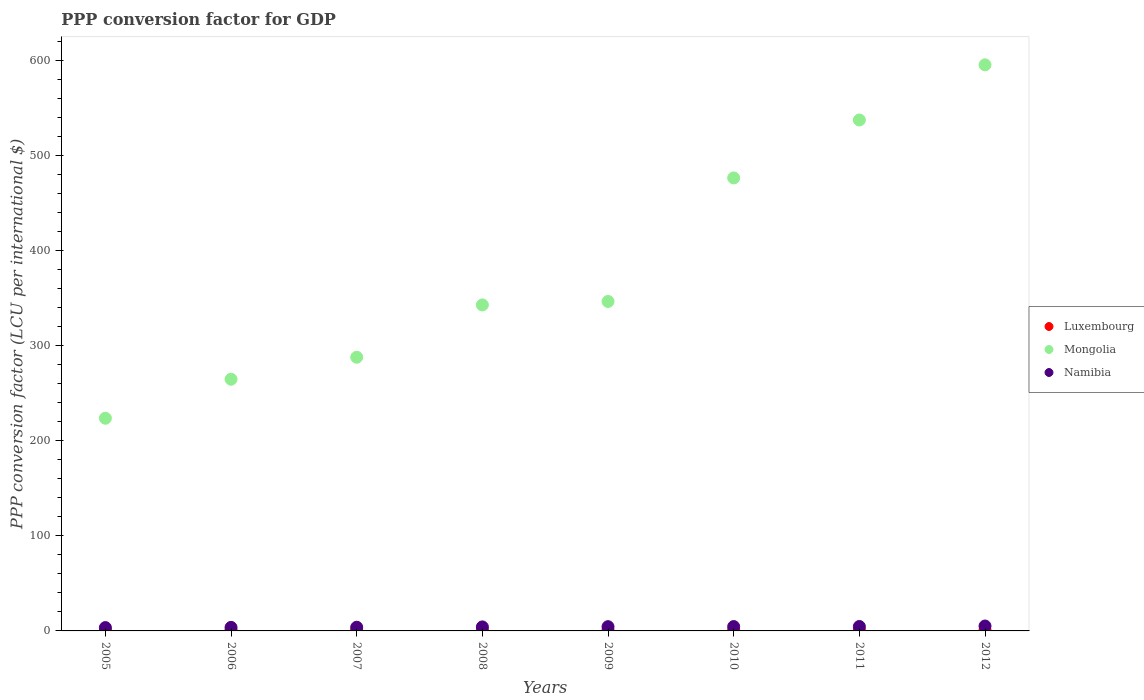What is the PPP conversion factor for GDP in Mongolia in 2012?
Provide a succinct answer. 595.11. Across all years, what is the maximum PPP conversion factor for GDP in Namibia?
Keep it short and to the point. 5.17. Across all years, what is the minimum PPP conversion factor for GDP in Mongolia?
Keep it short and to the point. 223.58. In which year was the PPP conversion factor for GDP in Mongolia maximum?
Provide a succinct answer. 2012. In which year was the PPP conversion factor for GDP in Luxembourg minimum?
Give a very brief answer. 2011. What is the total PPP conversion factor for GDP in Luxembourg in the graph?
Make the answer very short. 7.32. What is the difference between the PPP conversion factor for GDP in Mongolia in 2008 and that in 2011?
Provide a succinct answer. -194.41. What is the difference between the PPP conversion factor for GDP in Luxembourg in 2005 and the PPP conversion factor for GDP in Namibia in 2008?
Give a very brief answer. -3.27. What is the average PPP conversion factor for GDP in Namibia per year?
Your answer should be compact. 4.28. In the year 2007, what is the difference between the PPP conversion factor for GDP in Luxembourg and PPP conversion factor for GDP in Namibia?
Keep it short and to the point. -2.96. What is the ratio of the PPP conversion factor for GDP in Luxembourg in 2009 to that in 2011?
Offer a terse response. 1.01. Is the PPP conversion factor for GDP in Namibia in 2005 less than that in 2009?
Offer a terse response. Yes. What is the difference between the highest and the second highest PPP conversion factor for GDP in Luxembourg?
Offer a terse response. 0.03. What is the difference between the highest and the lowest PPP conversion factor for GDP in Mongolia?
Keep it short and to the point. 371.53. Does the PPP conversion factor for GDP in Mongolia monotonically increase over the years?
Offer a terse response. Yes. Is the PPP conversion factor for GDP in Luxembourg strictly less than the PPP conversion factor for GDP in Namibia over the years?
Offer a terse response. Yes. How many years are there in the graph?
Give a very brief answer. 8. What is the difference between two consecutive major ticks on the Y-axis?
Your response must be concise. 100. Are the values on the major ticks of Y-axis written in scientific E-notation?
Your response must be concise. No. Where does the legend appear in the graph?
Make the answer very short. Center right. What is the title of the graph?
Keep it short and to the point. PPP conversion factor for GDP. What is the label or title of the Y-axis?
Offer a terse response. PPP conversion factor (LCU per international $). What is the PPP conversion factor (LCU per international $) in Luxembourg in 2005?
Provide a succinct answer. 0.95. What is the PPP conversion factor (LCU per international $) of Mongolia in 2005?
Offer a very short reply. 223.58. What is the PPP conversion factor (LCU per international $) in Namibia in 2005?
Your answer should be compact. 3.52. What is the PPP conversion factor (LCU per international $) of Luxembourg in 2006?
Offer a terse response. 0.91. What is the PPP conversion factor (LCU per international $) in Mongolia in 2006?
Ensure brevity in your answer.  264.61. What is the PPP conversion factor (LCU per international $) of Namibia in 2006?
Provide a succinct answer. 3.73. What is the PPP conversion factor (LCU per international $) of Luxembourg in 2007?
Offer a very short reply. 0.92. What is the PPP conversion factor (LCU per international $) in Mongolia in 2007?
Your answer should be compact. 287.72. What is the PPP conversion factor (LCU per international $) in Namibia in 2007?
Make the answer very short. 3.88. What is the PPP conversion factor (LCU per international $) of Luxembourg in 2008?
Make the answer very short. 0.91. What is the PPP conversion factor (LCU per international $) in Mongolia in 2008?
Give a very brief answer. 342.71. What is the PPP conversion factor (LCU per international $) of Namibia in 2008?
Offer a very short reply. 4.22. What is the PPP conversion factor (LCU per international $) in Luxembourg in 2009?
Make the answer very short. 0.91. What is the PPP conversion factor (LCU per international $) of Mongolia in 2009?
Offer a terse response. 346.34. What is the PPP conversion factor (LCU per international $) of Namibia in 2009?
Offer a very short reply. 4.48. What is the PPP conversion factor (LCU per international $) of Luxembourg in 2010?
Offer a terse response. 0.92. What is the PPP conversion factor (LCU per international $) in Mongolia in 2010?
Provide a succinct answer. 476.22. What is the PPP conversion factor (LCU per international $) of Namibia in 2010?
Ensure brevity in your answer.  4.59. What is the PPP conversion factor (LCU per international $) of Luxembourg in 2011?
Your response must be concise. 0.89. What is the PPP conversion factor (LCU per international $) in Mongolia in 2011?
Your response must be concise. 537.13. What is the PPP conversion factor (LCU per international $) of Namibia in 2011?
Keep it short and to the point. 4.66. What is the PPP conversion factor (LCU per international $) of Luxembourg in 2012?
Your answer should be compact. 0.9. What is the PPP conversion factor (LCU per international $) of Mongolia in 2012?
Your response must be concise. 595.11. What is the PPP conversion factor (LCU per international $) in Namibia in 2012?
Make the answer very short. 5.17. Across all years, what is the maximum PPP conversion factor (LCU per international $) of Luxembourg?
Keep it short and to the point. 0.95. Across all years, what is the maximum PPP conversion factor (LCU per international $) of Mongolia?
Your answer should be compact. 595.11. Across all years, what is the maximum PPP conversion factor (LCU per international $) in Namibia?
Give a very brief answer. 5.17. Across all years, what is the minimum PPP conversion factor (LCU per international $) of Luxembourg?
Your answer should be compact. 0.89. Across all years, what is the minimum PPP conversion factor (LCU per international $) in Mongolia?
Ensure brevity in your answer.  223.58. Across all years, what is the minimum PPP conversion factor (LCU per international $) of Namibia?
Provide a short and direct response. 3.52. What is the total PPP conversion factor (LCU per international $) of Luxembourg in the graph?
Make the answer very short. 7.32. What is the total PPP conversion factor (LCU per international $) of Mongolia in the graph?
Offer a terse response. 3073.42. What is the total PPP conversion factor (LCU per international $) of Namibia in the graph?
Provide a succinct answer. 34.24. What is the difference between the PPP conversion factor (LCU per international $) of Luxembourg in 2005 and that in 2006?
Provide a short and direct response. 0.04. What is the difference between the PPP conversion factor (LCU per international $) in Mongolia in 2005 and that in 2006?
Give a very brief answer. -41.03. What is the difference between the PPP conversion factor (LCU per international $) in Namibia in 2005 and that in 2006?
Give a very brief answer. -0.21. What is the difference between the PPP conversion factor (LCU per international $) in Luxembourg in 2005 and that in 2007?
Keep it short and to the point. 0.03. What is the difference between the PPP conversion factor (LCU per international $) of Mongolia in 2005 and that in 2007?
Your answer should be compact. -64.14. What is the difference between the PPP conversion factor (LCU per international $) in Namibia in 2005 and that in 2007?
Ensure brevity in your answer.  -0.37. What is the difference between the PPP conversion factor (LCU per international $) of Luxembourg in 2005 and that in 2008?
Your response must be concise. 0.05. What is the difference between the PPP conversion factor (LCU per international $) of Mongolia in 2005 and that in 2008?
Make the answer very short. -119.13. What is the difference between the PPP conversion factor (LCU per international $) in Namibia in 2005 and that in 2008?
Your answer should be compact. -0.71. What is the difference between the PPP conversion factor (LCU per international $) of Luxembourg in 2005 and that in 2009?
Provide a succinct answer. 0.05. What is the difference between the PPP conversion factor (LCU per international $) in Mongolia in 2005 and that in 2009?
Your answer should be compact. -122.76. What is the difference between the PPP conversion factor (LCU per international $) of Namibia in 2005 and that in 2009?
Offer a terse response. -0.97. What is the difference between the PPP conversion factor (LCU per international $) of Luxembourg in 2005 and that in 2010?
Your answer should be compact. 0.03. What is the difference between the PPP conversion factor (LCU per international $) in Mongolia in 2005 and that in 2010?
Keep it short and to the point. -252.64. What is the difference between the PPP conversion factor (LCU per international $) in Namibia in 2005 and that in 2010?
Your answer should be compact. -1.07. What is the difference between the PPP conversion factor (LCU per international $) of Luxembourg in 2005 and that in 2011?
Your answer should be very brief. 0.06. What is the difference between the PPP conversion factor (LCU per international $) of Mongolia in 2005 and that in 2011?
Offer a very short reply. -313.55. What is the difference between the PPP conversion factor (LCU per international $) of Namibia in 2005 and that in 2011?
Your response must be concise. -1.15. What is the difference between the PPP conversion factor (LCU per international $) of Luxembourg in 2005 and that in 2012?
Offer a very short reply. 0.05. What is the difference between the PPP conversion factor (LCU per international $) in Mongolia in 2005 and that in 2012?
Your answer should be compact. -371.53. What is the difference between the PPP conversion factor (LCU per international $) in Namibia in 2005 and that in 2012?
Make the answer very short. -1.66. What is the difference between the PPP conversion factor (LCU per international $) in Luxembourg in 2006 and that in 2007?
Offer a terse response. -0.01. What is the difference between the PPP conversion factor (LCU per international $) in Mongolia in 2006 and that in 2007?
Provide a succinct answer. -23.11. What is the difference between the PPP conversion factor (LCU per international $) of Namibia in 2006 and that in 2007?
Make the answer very short. -0.15. What is the difference between the PPP conversion factor (LCU per international $) in Luxembourg in 2006 and that in 2008?
Your response must be concise. 0.01. What is the difference between the PPP conversion factor (LCU per international $) in Mongolia in 2006 and that in 2008?
Your answer should be compact. -78.1. What is the difference between the PPP conversion factor (LCU per international $) in Namibia in 2006 and that in 2008?
Offer a very short reply. -0.49. What is the difference between the PPP conversion factor (LCU per international $) in Luxembourg in 2006 and that in 2009?
Your answer should be compact. 0.01. What is the difference between the PPP conversion factor (LCU per international $) of Mongolia in 2006 and that in 2009?
Your answer should be very brief. -81.73. What is the difference between the PPP conversion factor (LCU per international $) in Namibia in 2006 and that in 2009?
Provide a short and direct response. -0.75. What is the difference between the PPP conversion factor (LCU per international $) of Luxembourg in 2006 and that in 2010?
Your answer should be very brief. -0.01. What is the difference between the PPP conversion factor (LCU per international $) in Mongolia in 2006 and that in 2010?
Ensure brevity in your answer.  -211.61. What is the difference between the PPP conversion factor (LCU per international $) in Namibia in 2006 and that in 2010?
Ensure brevity in your answer.  -0.86. What is the difference between the PPP conversion factor (LCU per international $) of Luxembourg in 2006 and that in 2011?
Provide a short and direct response. 0.02. What is the difference between the PPP conversion factor (LCU per international $) of Mongolia in 2006 and that in 2011?
Offer a very short reply. -272.52. What is the difference between the PPP conversion factor (LCU per international $) in Namibia in 2006 and that in 2011?
Make the answer very short. -0.94. What is the difference between the PPP conversion factor (LCU per international $) in Luxembourg in 2006 and that in 2012?
Make the answer very short. 0.02. What is the difference between the PPP conversion factor (LCU per international $) of Mongolia in 2006 and that in 2012?
Provide a succinct answer. -330.5. What is the difference between the PPP conversion factor (LCU per international $) of Namibia in 2006 and that in 2012?
Provide a succinct answer. -1.44. What is the difference between the PPP conversion factor (LCU per international $) in Luxembourg in 2007 and that in 2008?
Provide a short and direct response. 0.02. What is the difference between the PPP conversion factor (LCU per international $) in Mongolia in 2007 and that in 2008?
Give a very brief answer. -54.99. What is the difference between the PPP conversion factor (LCU per international $) of Namibia in 2007 and that in 2008?
Your answer should be compact. -0.34. What is the difference between the PPP conversion factor (LCU per international $) of Luxembourg in 2007 and that in 2009?
Offer a very short reply. 0.02. What is the difference between the PPP conversion factor (LCU per international $) in Mongolia in 2007 and that in 2009?
Provide a succinct answer. -58.62. What is the difference between the PPP conversion factor (LCU per international $) in Namibia in 2007 and that in 2009?
Your answer should be very brief. -0.6. What is the difference between the PPP conversion factor (LCU per international $) of Luxembourg in 2007 and that in 2010?
Ensure brevity in your answer.  0. What is the difference between the PPP conversion factor (LCU per international $) in Mongolia in 2007 and that in 2010?
Offer a terse response. -188.49. What is the difference between the PPP conversion factor (LCU per international $) in Namibia in 2007 and that in 2010?
Give a very brief answer. -0.7. What is the difference between the PPP conversion factor (LCU per international $) in Mongolia in 2007 and that in 2011?
Offer a terse response. -249.41. What is the difference between the PPP conversion factor (LCU per international $) in Namibia in 2007 and that in 2011?
Offer a very short reply. -0.78. What is the difference between the PPP conversion factor (LCU per international $) of Luxembourg in 2007 and that in 2012?
Provide a short and direct response. 0.03. What is the difference between the PPP conversion factor (LCU per international $) in Mongolia in 2007 and that in 2012?
Your answer should be compact. -307.39. What is the difference between the PPP conversion factor (LCU per international $) of Namibia in 2007 and that in 2012?
Ensure brevity in your answer.  -1.29. What is the difference between the PPP conversion factor (LCU per international $) in Luxembourg in 2008 and that in 2009?
Your answer should be compact. -0. What is the difference between the PPP conversion factor (LCU per international $) of Mongolia in 2008 and that in 2009?
Ensure brevity in your answer.  -3.63. What is the difference between the PPP conversion factor (LCU per international $) of Namibia in 2008 and that in 2009?
Offer a terse response. -0.26. What is the difference between the PPP conversion factor (LCU per international $) in Luxembourg in 2008 and that in 2010?
Provide a short and direct response. -0.02. What is the difference between the PPP conversion factor (LCU per international $) in Mongolia in 2008 and that in 2010?
Your answer should be very brief. -133.5. What is the difference between the PPP conversion factor (LCU per international $) in Namibia in 2008 and that in 2010?
Provide a short and direct response. -0.36. What is the difference between the PPP conversion factor (LCU per international $) in Luxembourg in 2008 and that in 2011?
Your response must be concise. 0.01. What is the difference between the PPP conversion factor (LCU per international $) in Mongolia in 2008 and that in 2011?
Provide a short and direct response. -194.41. What is the difference between the PPP conversion factor (LCU per international $) of Namibia in 2008 and that in 2011?
Your response must be concise. -0.44. What is the difference between the PPP conversion factor (LCU per international $) of Luxembourg in 2008 and that in 2012?
Make the answer very short. 0.01. What is the difference between the PPP conversion factor (LCU per international $) of Mongolia in 2008 and that in 2012?
Your answer should be compact. -252.4. What is the difference between the PPP conversion factor (LCU per international $) in Namibia in 2008 and that in 2012?
Your response must be concise. -0.95. What is the difference between the PPP conversion factor (LCU per international $) of Luxembourg in 2009 and that in 2010?
Offer a very short reply. -0.02. What is the difference between the PPP conversion factor (LCU per international $) of Mongolia in 2009 and that in 2010?
Provide a short and direct response. -129.87. What is the difference between the PPP conversion factor (LCU per international $) in Namibia in 2009 and that in 2010?
Offer a very short reply. -0.1. What is the difference between the PPP conversion factor (LCU per international $) of Luxembourg in 2009 and that in 2011?
Offer a terse response. 0.01. What is the difference between the PPP conversion factor (LCU per international $) in Mongolia in 2009 and that in 2011?
Keep it short and to the point. -190.78. What is the difference between the PPP conversion factor (LCU per international $) of Namibia in 2009 and that in 2011?
Make the answer very short. -0.18. What is the difference between the PPP conversion factor (LCU per international $) of Luxembourg in 2009 and that in 2012?
Offer a very short reply. 0.01. What is the difference between the PPP conversion factor (LCU per international $) in Mongolia in 2009 and that in 2012?
Make the answer very short. -248.77. What is the difference between the PPP conversion factor (LCU per international $) in Namibia in 2009 and that in 2012?
Make the answer very short. -0.69. What is the difference between the PPP conversion factor (LCU per international $) of Luxembourg in 2010 and that in 2011?
Offer a terse response. 0.03. What is the difference between the PPP conversion factor (LCU per international $) of Mongolia in 2010 and that in 2011?
Keep it short and to the point. -60.91. What is the difference between the PPP conversion factor (LCU per international $) of Namibia in 2010 and that in 2011?
Provide a succinct answer. -0.08. What is the difference between the PPP conversion factor (LCU per international $) in Luxembourg in 2010 and that in 2012?
Give a very brief answer. 0.02. What is the difference between the PPP conversion factor (LCU per international $) in Mongolia in 2010 and that in 2012?
Offer a very short reply. -118.9. What is the difference between the PPP conversion factor (LCU per international $) in Namibia in 2010 and that in 2012?
Make the answer very short. -0.59. What is the difference between the PPP conversion factor (LCU per international $) of Luxembourg in 2011 and that in 2012?
Give a very brief answer. -0. What is the difference between the PPP conversion factor (LCU per international $) in Mongolia in 2011 and that in 2012?
Your answer should be compact. -57.98. What is the difference between the PPP conversion factor (LCU per international $) of Namibia in 2011 and that in 2012?
Your answer should be very brief. -0.51. What is the difference between the PPP conversion factor (LCU per international $) of Luxembourg in 2005 and the PPP conversion factor (LCU per international $) of Mongolia in 2006?
Your answer should be very brief. -263.66. What is the difference between the PPP conversion factor (LCU per international $) in Luxembourg in 2005 and the PPP conversion factor (LCU per international $) in Namibia in 2006?
Provide a succinct answer. -2.77. What is the difference between the PPP conversion factor (LCU per international $) in Mongolia in 2005 and the PPP conversion factor (LCU per international $) in Namibia in 2006?
Your response must be concise. 219.85. What is the difference between the PPP conversion factor (LCU per international $) in Luxembourg in 2005 and the PPP conversion factor (LCU per international $) in Mongolia in 2007?
Offer a terse response. -286.77. What is the difference between the PPP conversion factor (LCU per international $) in Luxembourg in 2005 and the PPP conversion factor (LCU per international $) in Namibia in 2007?
Your answer should be very brief. -2.93. What is the difference between the PPP conversion factor (LCU per international $) of Mongolia in 2005 and the PPP conversion factor (LCU per international $) of Namibia in 2007?
Offer a terse response. 219.7. What is the difference between the PPP conversion factor (LCU per international $) of Luxembourg in 2005 and the PPP conversion factor (LCU per international $) of Mongolia in 2008?
Provide a succinct answer. -341.76. What is the difference between the PPP conversion factor (LCU per international $) in Luxembourg in 2005 and the PPP conversion factor (LCU per international $) in Namibia in 2008?
Make the answer very short. -3.27. What is the difference between the PPP conversion factor (LCU per international $) of Mongolia in 2005 and the PPP conversion factor (LCU per international $) of Namibia in 2008?
Your answer should be very brief. 219.36. What is the difference between the PPP conversion factor (LCU per international $) of Luxembourg in 2005 and the PPP conversion factor (LCU per international $) of Mongolia in 2009?
Make the answer very short. -345.39. What is the difference between the PPP conversion factor (LCU per international $) of Luxembourg in 2005 and the PPP conversion factor (LCU per international $) of Namibia in 2009?
Ensure brevity in your answer.  -3.53. What is the difference between the PPP conversion factor (LCU per international $) in Mongolia in 2005 and the PPP conversion factor (LCU per international $) in Namibia in 2009?
Give a very brief answer. 219.1. What is the difference between the PPP conversion factor (LCU per international $) in Luxembourg in 2005 and the PPP conversion factor (LCU per international $) in Mongolia in 2010?
Your response must be concise. -475.26. What is the difference between the PPP conversion factor (LCU per international $) of Luxembourg in 2005 and the PPP conversion factor (LCU per international $) of Namibia in 2010?
Give a very brief answer. -3.63. What is the difference between the PPP conversion factor (LCU per international $) in Mongolia in 2005 and the PPP conversion factor (LCU per international $) in Namibia in 2010?
Your answer should be very brief. 219. What is the difference between the PPP conversion factor (LCU per international $) in Luxembourg in 2005 and the PPP conversion factor (LCU per international $) in Mongolia in 2011?
Your response must be concise. -536.17. What is the difference between the PPP conversion factor (LCU per international $) of Luxembourg in 2005 and the PPP conversion factor (LCU per international $) of Namibia in 2011?
Keep it short and to the point. -3.71. What is the difference between the PPP conversion factor (LCU per international $) of Mongolia in 2005 and the PPP conversion factor (LCU per international $) of Namibia in 2011?
Keep it short and to the point. 218.92. What is the difference between the PPP conversion factor (LCU per international $) of Luxembourg in 2005 and the PPP conversion factor (LCU per international $) of Mongolia in 2012?
Your answer should be very brief. -594.16. What is the difference between the PPP conversion factor (LCU per international $) in Luxembourg in 2005 and the PPP conversion factor (LCU per international $) in Namibia in 2012?
Give a very brief answer. -4.22. What is the difference between the PPP conversion factor (LCU per international $) in Mongolia in 2005 and the PPP conversion factor (LCU per international $) in Namibia in 2012?
Give a very brief answer. 218.41. What is the difference between the PPP conversion factor (LCU per international $) in Luxembourg in 2006 and the PPP conversion factor (LCU per international $) in Mongolia in 2007?
Your answer should be compact. -286.81. What is the difference between the PPP conversion factor (LCU per international $) in Luxembourg in 2006 and the PPP conversion factor (LCU per international $) in Namibia in 2007?
Your answer should be compact. -2.97. What is the difference between the PPP conversion factor (LCU per international $) of Mongolia in 2006 and the PPP conversion factor (LCU per international $) of Namibia in 2007?
Make the answer very short. 260.73. What is the difference between the PPP conversion factor (LCU per international $) of Luxembourg in 2006 and the PPP conversion factor (LCU per international $) of Mongolia in 2008?
Make the answer very short. -341.8. What is the difference between the PPP conversion factor (LCU per international $) of Luxembourg in 2006 and the PPP conversion factor (LCU per international $) of Namibia in 2008?
Your answer should be very brief. -3.31. What is the difference between the PPP conversion factor (LCU per international $) in Mongolia in 2006 and the PPP conversion factor (LCU per international $) in Namibia in 2008?
Give a very brief answer. 260.39. What is the difference between the PPP conversion factor (LCU per international $) of Luxembourg in 2006 and the PPP conversion factor (LCU per international $) of Mongolia in 2009?
Keep it short and to the point. -345.43. What is the difference between the PPP conversion factor (LCU per international $) of Luxembourg in 2006 and the PPP conversion factor (LCU per international $) of Namibia in 2009?
Ensure brevity in your answer.  -3.57. What is the difference between the PPP conversion factor (LCU per international $) in Mongolia in 2006 and the PPP conversion factor (LCU per international $) in Namibia in 2009?
Provide a short and direct response. 260.13. What is the difference between the PPP conversion factor (LCU per international $) in Luxembourg in 2006 and the PPP conversion factor (LCU per international $) in Mongolia in 2010?
Your answer should be very brief. -475.3. What is the difference between the PPP conversion factor (LCU per international $) of Luxembourg in 2006 and the PPP conversion factor (LCU per international $) of Namibia in 2010?
Give a very brief answer. -3.67. What is the difference between the PPP conversion factor (LCU per international $) of Mongolia in 2006 and the PPP conversion factor (LCU per international $) of Namibia in 2010?
Provide a short and direct response. 260.02. What is the difference between the PPP conversion factor (LCU per international $) in Luxembourg in 2006 and the PPP conversion factor (LCU per international $) in Mongolia in 2011?
Keep it short and to the point. -536.21. What is the difference between the PPP conversion factor (LCU per international $) of Luxembourg in 2006 and the PPP conversion factor (LCU per international $) of Namibia in 2011?
Ensure brevity in your answer.  -3.75. What is the difference between the PPP conversion factor (LCU per international $) in Mongolia in 2006 and the PPP conversion factor (LCU per international $) in Namibia in 2011?
Your answer should be very brief. 259.95. What is the difference between the PPP conversion factor (LCU per international $) of Luxembourg in 2006 and the PPP conversion factor (LCU per international $) of Mongolia in 2012?
Give a very brief answer. -594.2. What is the difference between the PPP conversion factor (LCU per international $) of Luxembourg in 2006 and the PPP conversion factor (LCU per international $) of Namibia in 2012?
Your answer should be compact. -4.26. What is the difference between the PPP conversion factor (LCU per international $) in Mongolia in 2006 and the PPP conversion factor (LCU per international $) in Namibia in 2012?
Your answer should be very brief. 259.44. What is the difference between the PPP conversion factor (LCU per international $) in Luxembourg in 2007 and the PPP conversion factor (LCU per international $) in Mongolia in 2008?
Provide a short and direct response. -341.79. What is the difference between the PPP conversion factor (LCU per international $) of Luxembourg in 2007 and the PPP conversion factor (LCU per international $) of Namibia in 2008?
Keep it short and to the point. -3.3. What is the difference between the PPP conversion factor (LCU per international $) in Mongolia in 2007 and the PPP conversion factor (LCU per international $) in Namibia in 2008?
Make the answer very short. 283.5. What is the difference between the PPP conversion factor (LCU per international $) of Luxembourg in 2007 and the PPP conversion factor (LCU per international $) of Mongolia in 2009?
Provide a short and direct response. -345.42. What is the difference between the PPP conversion factor (LCU per international $) of Luxembourg in 2007 and the PPP conversion factor (LCU per international $) of Namibia in 2009?
Keep it short and to the point. -3.56. What is the difference between the PPP conversion factor (LCU per international $) of Mongolia in 2007 and the PPP conversion factor (LCU per international $) of Namibia in 2009?
Your response must be concise. 283.24. What is the difference between the PPP conversion factor (LCU per international $) in Luxembourg in 2007 and the PPP conversion factor (LCU per international $) in Mongolia in 2010?
Your answer should be very brief. -475.29. What is the difference between the PPP conversion factor (LCU per international $) in Luxembourg in 2007 and the PPP conversion factor (LCU per international $) in Namibia in 2010?
Keep it short and to the point. -3.66. What is the difference between the PPP conversion factor (LCU per international $) of Mongolia in 2007 and the PPP conversion factor (LCU per international $) of Namibia in 2010?
Offer a very short reply. 283.14. What is the difference between the PPP conversion factor (LCU per international $) in Luxembourg in 2007 and the PPP conversion factor (LCU per international $) in Mongolia in 2011?
Offer a very short reply. -536.2. What is the difference between the PPP conversion factor (LCU per international $) of Luxembourg in 2007 and the PPP conversion factor (LCU per international $) of Namibia in 2011?
Offer a very short reply. -3.74. What is the difference between the PPP conversion factor (LCU per international $) of Mongolia in 2007 and the PPP conversion factor (LCU per international $) of Namibia in 2011?
Your response must be concise. 283.06. What is the difference between the PPP conversion factor (LCU per international $) in Luxembourg in 2007 and the PPP conversion factor (LCU per international $) in Mongolia in 2012?
Provide a succinct answer. -594.19. What is the difference between the PPP conversion factor (LCU per international $) in Luxembourg in 2007 and the PPP conversion factor (LCU per international $) in Namibia in 2012?
Your answer should be very brief. -4.25. What is the difference between the PPP conversion factor (LCU per international $) in Mongolia in 2007 and the PPP conversion factor (LCU per international $) in Namibia in 2012?
Offer a terse response. 282.55. What is the difference between the PPP conversion factor (LCU per international $) of Luxembourg in 2008 and the PPP conversion factor (LCU per international $) of Mongolia in 2009?
Ensure brevity in your answer.  -345.44. What is the difference between the PPP conversion factor (LCU per international $) of Luxembourg in 2008 and the PPP conversion factor (LCU per international $) of Namibia in 2009?
Your answer should be very brief. -3.58. What is the difference between the PPP conversion factor (LCU per international $) in Mongolia in 2008 and the PPP conversion factor (LCU per international $) in Namibia in 2009?
Keep it short and to the point. 338.23. What is the difference between the PPP conversion factor (LCU per international $) of Luxembourg in 2008 and the PPP conversion factor (LCU per international $) of Mongolia in 2010?
Make the answer very short. -475.31. What is the difference between the PPP conversion factor (LCU per international $) in Luxembourg in 2008 and the PPP conversion factor (LCU per international $) in Namibia in 2010?
Keep it short and to the point. -3.68. What is the difference between the PPP conversion factor (LCU per international $) of Mongolia in 2008 and the PPP conversion factor (LCU per international $) of Namibia in 2010?
Your answer should be very brief. 338.13. What is the difference between the PPP conversion factor (LCU per international $) in Luxembourg in 2008 and the PPP conversion factor (LCU per international $) in Mongolia in 2011?
Provide a succinct answer. -536.22. What is the difference between the PPP conversion factor (LCU per international $) in Luxembourg in 2008 and the PPP conversion factor (LCU per international $) in Namibia in 2011?
Offer a terse response. -3.76. What is the difference between the PPP conversion factor (LCU per international $) in Mongolia in 2008 and the PPP conversion factor (LCU per international $) in Namibia in 2011?
Your answer should be compact. 338.05. What is the difference between the PPP conversion factor (LCU per international $) of Luxembourg in 2008 and the PPP conversion factor (LCU per international $) of Mongolia in 2012?
Provide a succinct answer. -594.21. What is the difference between the PPP conversion factor (LCU per international $) of Luxembourg in 2008 and the PPP conversion factor (LCU per international $) of Namibia in 2012?
Offer a very short reply. -4.26. What is the difference between the PPP conversion factor (LCU per international $) in Mongolia in 2008 and the PPP conversion factor (LCU per international $) in Namibia in 2012?
Keep it short and to the point. 337.54. What is the difference between the PPP conversion factor (LCU per international $) of Luxembourg in 2009 and the PPP conversion factor (LCU per international $) of Mongolia in 2010?
Ensure brevity in your answer.  -475.31. What is the difference between the PPP conversion factor (LCU per international $) in Luxembourg in 2009 and the PPP conversion factor (LCU per international $) in Namibia in 2010?
Keep it short and to the point. -3.68. What is the difference between the PPP conversion factor (LCU per international $) in Mongolia in 2009 and the PPP conversion factor (LCU per international $) in Namibia in 2010?
Provide a short and direct response. 341.76. What is the difference between the PPP conversion factor (LCU per international $) in Luxembourg in 2009 and the PPP conversion factor (LCU per international $) in Mongolia in 2011?
Your answer should be compact. -536.22. What is the difference between the PPP conversion factor (LCU per international $) in Luxembourg in 2009 and the PPP conversion factor (LCU per international $) in Namibia in 2011?
Ensure brevity in your answer.  -3.76. What is the difference between the PPP conversion factor (LCU per international $) in Mongolia in 2009 and the PPP conversion factor (LCU per international $) in Namibia in 2011?
Your answer should be very brief. 341.68. What is the difference between the PPP conversion factor (LCU per international $) of Luxembourg in 2009 and the PPP conversion factor (LCU per international $) of Mongolia in 2012?
Keep it short and to the point. -594.2. What is the difference between the PPP conversion factor (LCU per international $) of Luxembourg in 2009 and the PPP conversion factor (LCU per international $) of Namibia in 2012?
Keep it short and to the point. -4.26. What is the difference between the PPP conversion factor (LCU per international $) in Mongolia in 2009 and the PPP conversion factor (LCU per international $) in Namibia in 2012?
Offer a very short reply. 341.17. What is the difference between the PPP conversion factor (LCU per international $) of Luxembourg in 2010 and the PPP conversion factor (LCU per international $) of Mongolia in 2011?
Offer a very short reply. -536.2. What is the difference between the PPP conversion factor (LCU per international $) of Luxembourg in 2010 and the PPP conversion factor (LCU per international $) of Namibia in 2011?
Your response must be concise. -3.74. What is the difference between the PPP conversion factor (LCU per international $) in Mongolia in 2010 and the PPP conversion factor (LCU per international $) in Namibia in 2011?
Your response must be concise. 471.55. What is the difference between the PPP conversion factor (LCU per international $) in Luxembourg in 2010 and the PPP conversion factor (LCU per international $) in Mongolia in 2012?
Offer a terse response. -594.19. What is the difference between the PPP conversion factor (LCU per international $) of Luxembourg in 2010 and the PPP conversion factor (LCU per international $) of Namibia in 2012?
Keep it short and to the point. -4.25. What is the difference between the PPP conversion factor (LCU per international $) in Mongolia in 2010 and the PPP conversion factor (LCU per international $) in Namibia in 2012?
Give a very brief answer. 471.04. What is the difference between the PPP conversion factor (LCU per international $) of Luxembourg in 2011 and the PPP conversion factor (LCU per international $) of Mongolia in 2012?
Your response must be concise. -594.22. What is the difference between the PPP conversion factor (LCU per international $) in Luxembourg in 2011 and the PPP conversion factor (LCU per international $) in Namibia in 2012?
Offer a terse response. -4.28. What is the difference between the PPP conversion factor (LCU per international $) in Mongolia in 2011 and the PPP conversion factor (LCU per international $) in Namibia in 2012?
Ensure brevity in your answer.  531.96. What is the average PPP conversion factor (LCU per international $) of Luxembourg per year?
Your response must be concise. 0.92. What is the average PPP conversion factor (LCU per international $) in Mongolia per year?
Offer a very short reply. 384.18. What is the average PPP conversion factor (LCU per international $) in Namibia per year?
Give a very brief answer. 4.28. In the year 2005, what is the difference between the PPP conversion factor (LCU per international $) of Luxembourg and PPP conversion factor (LCU per international $) of Mongolia?
Your answer should be compact. -222.63. In the year 2005, what is the difference between the PPP conversion factor (LCU per international $) of Luxembourg and PPP conversion factor (LCU per international $) of Namibia?
Provide a short and direct response. -2.56. In the year 2005, what is the difference between the PPP conversion factor (LCU per international $) in Mongolia and PPP conversion factor (LCU per international $) in Namibia?
Your answer should be very brief. 220.06. In the year 2006, what is the difference between the PPP conversion factor (LCU per international $) in Luxembourg and PPP conversion factor (LCU per international $) in Mongolia?
Keep it short and to the point. -263.69. In the year 2006, what is the difference between the PPP conversion factor (LCU per international $) in Luxembourg and PPP conversion factor (LCU per international $) in Namibia?
Your response must be concise. -2.81. In the year 2006, what is the difference between the PPP conversion factor (LCU per international $) of Mongolia and PPP conversion factor (LCU per international $) of Namibia?
Ensure brevity in your answer.  260.88. In the year 2007, what is the difference between the PPP conversion factor (LCU per international $) in Luxembourg and PPP conversion factor (LCU per international $) in Mongolia?
Offer a very short reply. -286.8. In the year 2007, what is the difference between the PPP conversion factor (LCU per international $) of Luxembourg and PPP conversion factor (LCU per international $) of Namibia?
Your answer should be very brief. -2.96. In the year 2007, what is the difference between the PPP conversion factor (LCU per international $) in Mongolia and PPP conversion factor (LCU per international $) in Namibia?
Make the answer very short. 283.84. In the year 2008, what is the difference between the PPP conversion factor (LCU per international $) in Luxembourg and PPP conversion factor (LCU per international $) in Mongolia?
Provide a short and direct response. -341.81. In the year 2008, what is the difference between the PPP conversion factor (LCU per international $) in Luxembourg and PPP conversion factor (LCU per international $) in Namibia?
Keep it short and to the point. -3.32. In the year 2008, what is the difference between the PPP conversion factor (LCU per international $) of Mongolia and PPP conversion factor (LCU per international $) of Namibia?
Keep it short and to the point. 338.49. In the year 2009, what is the difference between the PPP conversion factor (LCU per international $) of Luxembourg and PPP conversion factor (LCU per international $) of Mongolia?
Your response must be concise. -345.43. In the year 2009, what is the difference between the PPP conversion factor (LCU per international $) of Luxembourg and PPP conversion factor (LCU per international $) of Namibia?
Your answer should be very brief. -3.57. In the year 2009, what is the difference between the PPP conversion factor (LCU per international $) of Mongolia and PPP conversion factor (LCU per international $) of Namibia?
Your answer should be very brief. 341.86. In the year 2010, what is the difference between the PPP conversion factor (LCU per international $) of Luxembourg and PPP conversion factor (LCU per international $) of Mongolia?
Offer a terse response. -475.29. In the year 2010, what is the difference between the PPP conversion factor (LCU per international $) of Luxembourg and PPP conversion factor (LCU per international $) of Namibia?
Offer a very short reply. -3.66. In the year 2010, what is the difference between the PPP conversion factor (LCU per international $) of Mongolia and PPP conversion factor (LCU per international $) of Namibia?
Ensure brevity in your answer.  471.63. In the year 2011, what is the difference between the PPP conversion factor (LCU per international $) of Luxembourg and PPP conversion factor (LCU per international $) of Mongolia?
Your answer should be very brief. -536.23. In the year 2011, what is the difference between the PPP conversion factor (LCU per international $) of Luxembourg and PPP conversion factor (LCU per international $) of Namibia?
Provide a short and direct response. -3.77. In the year 2011, what is the difference between the PPP conversion factor (LCU per international $) of Mongolia and PPP conversion factor (LCU per international $) of Namibia?
Offer a very short reply. 532.46. In the year 2012, what is the difference between the PPP conversion factor (LCU per international $) in Luxembourg and PPP conversion factor (LCU per international $) in Mongolia?
Ensure brevity in your answer.  -594.21. In the year 2012, what is the difference between the PPP conversion factor (LCU per international $) of Luxembourg and PPP conversion factor (LCU per international $) of Namibia?
Make the answer very short. -4.27. In the year 2012, what is the difference between the PPP conversion factor (LCU per international $) of Mongolia and PPP conversion factor (LCU per international $) of Namibia?
Your response must be concise. 589.94. What is the ratio of the PPP conversion factor (LCU per international $) of Luxembourg in 2005 to that in 2006?
Provide a short and direct response. 1.04. What is the ratio of the PPP conversion factor (LCU per international $) in Mongolia in 2005 to that in 2006?
Offer a very short reply. 0.84. What is the ratio of the PPP conversion factor (LCU per international $) in Namibia in 2005 to that in 2006?
Your answer should be compact. 0.94. What is the ratio of the PPP conversion factor (LCU per international $) in Luxembourg in 2005 to that in 2007?
Your answer should be very brief. 1.03. What is the ratio of the PPP conversion factor (LCU per international $) in Mongolia in 2005 to that in 2007?
Ensure brevity in your answer.  0.78. What is the ratio of the PPP conversion factor (LCU per international $) in Namibia in 2005 to that in 2007?
Keep it short and to the point. 0.91. What is the ratio of the PPP conversion factor (LCU per international $) in Luxembourg in 2005 to that in 2008?
Give a very brief answer. 1.05. What is the ratio of the PPP conversion factor (LCU per international $) in Mongolia in 2005 to that in 2008?
Ensure brevity in your answer.  0.65. What is the ratio of the PPP conversion factor (LCU per international $) in Namibia in 2005 to that in 2008?
Your answer should be compact. 0.83. What is the ratio of the PPP conversion factor (LCU per international $) in Luxembourg in 2005 to that in 2009?
Offer a very short reply. 1.05. What is the ratio of the PPP conversion factor (LCU per international $) of Mongolia in 2005 to that in 2009?
Give a very brief answer. 0.65. What is the ratio of the PPP conversion factor (LCU per international $) in Namibia in 2005 to that in 2009?
Make the answer very short. 0.78. What is the ratio of the PPP conversion factor (LCU per international $) of Luxembourg in 2005 to that in 2010?
Your answer should be very brief. 1.03. What is the ratio of the PPP conversion factor (LCU per international $) in Mongolia in 2005 to that in 2010?
Provide a short and direct response. 0.47. What is the ratio of the PPP conversion factor (LCU per international $) in Namibia in 2005 to that in 2010?
Provide a succinct answer. 0.77. What is the ratio of the PPP conversion factor (LCU per international $) in Luxembourg in 2005 to that in 2011?
Provide a succinct answer. 1.07. What is the ratio of the PPP conversion factor (LCU per international $) in Mongolia in 2005 to that in 2011?
Offer a very short reply. 0.42. What is the ratio of the PPP conversion factor (LCU per international $) of Namibia in 2005 to that in 2011?
Give a very brief answer. 0.75. What is the ratio of the PPP conversion factor (LCU per international $) of Luxembourg in 2005 to that in 2012?
Make the answer very short. 1.06. What is the ratio of the PPP conversion factor (LCU per international $) of Mongolia in 2005 to that in 2012?
Give a very brief answer. 0.38. What is the ratio of the PPP conversion factor (LCU per international $) in Namibia in 2005 to that in 2012?
Keep it short and to the point. 0.68. What is the ratio of the PPP conversion factor (LCU per international $) of Mongolia in 2006 to that in 2007?
Offer a terse response. 0.92. What is the ratio of the PPP conversion factor (LCU per international $) in Namibia in 2006 to that in 2007?
Make the answer very short. 0.96. What is the ratio of the PPP conversion factor (LCU per international $) in Luxembourg in 2006 to that in 2008?
Your answer should be compact. 1.01. What is the ratio of the PPP conversion factor (LCU per international $) of Mongolia in 2006 to that in 2008?
Your answer should be very brief. 0.77. What is the ratio of the PPP conversion factor (LCU per international $) in Namibia in 2006 to that in 2008?
Offer a very short reply. 0.88. What is the ratio of the PPP conversion factor (LCU per international $) in Luxembourg in 2006 to that in 2009?
Make the answer very short. 1.01. What is the ratio of the PPP conversion factor (LCU per international $) in Mongolia in 2006 to that in 2009?
Your answer should be very brief. 0.76. What is the ratio of the PPP conversion factor (LCU per international $) in Namibia in 2006 to that in 2009?
Give a very brief answer. 0.83. What is the ratio of the PPP conversion factor (LCU per international $) in Luxembourg in 2006 to that in 2010?
Give a very brief answer. 0.99. What is the ratio of the PPP conversion factor (LCU per international $) of Mongolia in 2006 to that in 2010?
Offer a very short reply. 0.56. What is the ratio of the PPP conversion factor (LCU per international $) in Namibia in 2006 to that in 2010?
Offer a terse response. 0.81. What is the ratio of the PPP conversion factor (LCU per international $) of Luxembourg in 2006 to that in 2011?
Give a very brief answer. 1.02. What is the ratio of the PPP conversion factor (LCU per international $) of Mongolia in 2006 to that in 2011?
Your answer should be compact. 0.49. What is the ratio of the PPP conversion factor (LCU per international $) of Namibia in 2006 to that in 2011?
Offer a terse response. 0.8. What is the ratio of the PPP conversion factor (LCU per international $) of Luxembourg in 2006 to that in 2012?
Keep it short and to the point. 1.02. What is the ratio of the PPP conversion factor (LCU per international $) of Mongolia in 2006 to that in 2012?
Your answer should be very brief. 0.44. What is the ratio of the PPP conversion factor (LCU per international $) of Namibia in 2006 to that in 2012?
Offer a terse response. 0.72. What is the ratio of the PPP conversion factor (LCU per international $) of Luxembourg in 2007 to that in 2008?
Ensure brevity in your answer.  1.02. What is the ratio of the PPP conversion factor (LCU per international $) in Mongolia in 2007 to that in 2008?
Offer a very short reply. 0.84. What is the ratio of the PPP conversion factor (LCU per international $) of Namibia in 2007 to that in 2008?
Provide a succinct answer. 0.92. What is the ratio of the PPP conversion factor (LCU per international $) of Luxembourg in 2007 to that in 2009?
Ensure brevity in your answer.  1.02. What is the ratio of the PPP conversion factor (LCU per international $) in Mongolia in 2007 to that in 2009?
Provide a succinct answer. 0.83. What is the ratio of the PPP conversion factor (LCU per international $) of Namibia in 2007 to that in 2009?
Provide a short and direct response. 0.87. What is the ratio of the PPP conversion factor (LCU per international $) of Mongolia in 2007 to that in 2010?
Your answer should be compact. 0.6. What is the ratio of the PPP conversion factor (LCU per international $) in Namibia in 2007 to that in 2010?
Offer a very short reply. 0.85. What is the ratio of the PPP conversion factor (LCU per international $) of Luxembourg in 2007 to that in 2011?
Your answer should be compact. 1.03. What is the ratio of the PPP conversion factor (LCU per international $) in Mongolia in 2007 to that in 2011?
Offer a very short reply. 0.54. What is the ratio of the PPP conversion factor (LCU per international $) in Namibia in 2007 to that in 2011?
Your answer should be very brief. 0.83. What is the ratio of the PPP conversion factor (LCU per international $) in Luxembourg in 2007 to that in 2012?
Keep it short and to the point. 1.03. What is the ratio of the PPP conversion factor (LCU per international $) in Mongolia in 2007 to that in 2012?
Offer a very short reply. 0.48. What is the ratio of the PPP conversion factor (LCU per international $) in Namibia in 2007 to that in 2012?
Make the answer very short. 0.75. What is the ratio of the PPP conversion factor (LCU per international $) of Luxembourg in 2008 to that in 2009?
Give a very brief answer. 1. What is the ratio of the PPP conversion factor (LCU per international $) in Mongolia in 2008 to that in 2009?
Ensure brevity in your answer.  0.99. What is the ratio of the PPP conversion factor (LCU per international $) of Namibia in 2008 to that in 2009?
Provide a short and direct response. 0.94. What is the ratio of the PPP conversion factor (LCU per international $) in Luxembourg in 2008 to that in 2010?
Make the answer very short. 0.98. What is the ratio of the PPP conversion factor (LCU per international $) in Mongolia in 2008 to that in 2010?
Your answer should be compact. 0.72. What is the ratio of the PPP conversion factor (LCU per international $) in Namibia in 2008 to that in 2010?
Offer a terse response. 0.92. What is the ratio of the PPP conversion factor (LCU per international $) in Luxembourg in 2008 to that in 2011?
Offer a terse response. 1.01. What is the ratio of the PPP conversion factor (LCU per international $) in Mongolia in 2008 to that in 2011?
Offer a very short reply. 0.64. What is the ratio of the PPP conversion factor (LCU per international $) in Namibia in 2008 to that in 2011?
Offer a terse response. 0.91. What is the ratio of the PPP conversion factor (LCU per international $) of Luxembourg in 2008 to that in 2012?
Ensure brevity in your answer.  1.01. What is the ratio of the PPP conversion factor (LCU per international $) of Mongolia in 2008 to that in 2012?
Your response must be concise. 0.58. What is the ratio of the PPP conversion factor (LCU per international $) in Namibia in 2008 to that in 2012?
Your answer should be very brief. 0.82. What is the ratio of the PPP conversion factor (LCU per international $) in Luxembourg in 2009 to that in 2010?
Provide a succinct answer. 0.98. What is the ratio of the PPP conversion factor (LCU per international $) in Mongolia in 2009 to that in 2010?
Give a very brief answer. 0.73. What is the ratio of the PPP conversion factor (LCU per international $) of Namibia in 2009 to that in 2010?
Keep it short and to the point. 0.98. What is the ratio of the PPP conversion factor (LCU per international $) of Mongolia in 2009 to that in 2011?
Offer a terse response. 0.64. What is the ratio of the PPP conversion factor (LCU per international $) of Luxembourg in 2009 to that in 2012?
Offer a very short reply. 1.01. What is the ratio of the PPP conversion factor (LCU per international $) of Mongolia in 2009 to that in 2012?
Your answer should be compact. 0.58. What is the ratio of the PPP conversion factor (LCU per international $) of Namibia in 2009 to that in 2012?
Your response must be concise. 0.87. What is the ratio of the PPP conversion factor (LCU per international $) in Luxembourg in 2010 to that in 2011?
Give a very brief answer. 1.03. What is the ratio of the PPP conversion factor (LCU per international $) of Mongolia in 2010 to that in 2011?
Your answer should be very brief. 0.89. What is the ratio of the PPP conversion factor (LCU per international $) in Namibia in 2010 to that in 2011?
Provide a succinct answer. 0.98. What is the ratio of the PPP conversion factor (LCU per international $) of Luxembourg in 2010 to that in 2012?
Offer a very short reply. 1.03. What is the ratio of the PPP conversion factor (LCU per international $) in Mongolia in 2010 to that in 2012?
Make the answer very short. 0.8. What is the ratio of the PPP conversion factor (LCU per international $) in Namibia in 2010 to that in 2012?
Make the answer very short. 0.89. What is the ratio of the PPP conversion factor (LCU per international $) in Mongolia in 2011 to that in 2012?
Your response must be concise. 0.9. What is the ratio of the PPP conversion factor (LCU per international $) in Namibia in 2011 to that in 2012?
Keep it short and to the point. 0.9. What is the difference between the highest and the second highest PPP conversion factor (LCU per international $) of Luxembourg?
Your answer should be very brief. 0.03. What is the difference between the highest and the second highest PPP conversion factor (LCU per international $) in Mongolia?
Offer a very short reply. 57.98. What is the difference between the highest and the second highest PPP conversion factor (LCU per international $) of Namibia?
Your answer should be very brief. 0.51. What is the difference between the highest and the lowest PPP conversion factor (LCU per international $) of Luxembourg?
Your answer should be compact. 0.06. What is the difference between the highest and the lowest PPP conversion factor (LCU per international $) in Mongolia?
Provide a short and direct response. 371.53. What is the difference between the highest and the lowest PPP conversion factor (LCU per international $) of Namibia?
Keep it short and to the point. 1.66. 